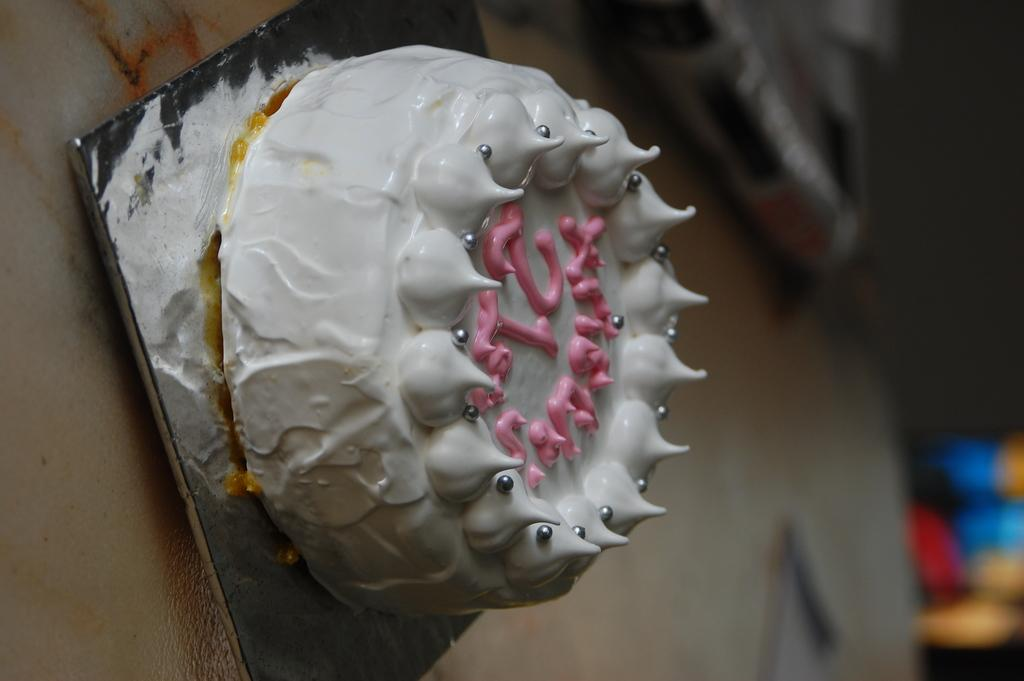In which direction is the image taken? The image is in the right side direction. What is the main subject of the image? There is a white color cake in the image. Are there any words or designs on the cake? Yes, there is text on the cake. What can be seen in the background of the image? There are objects visible at the back of the image. What type of wine is being served with the crackers in the image? There is no wine or crackers present in the image; it features a white color cake with text on it. Is there any snow visible in the image? There is no snow present in the image; it is focused on a cake with text on it and objects in the background. 